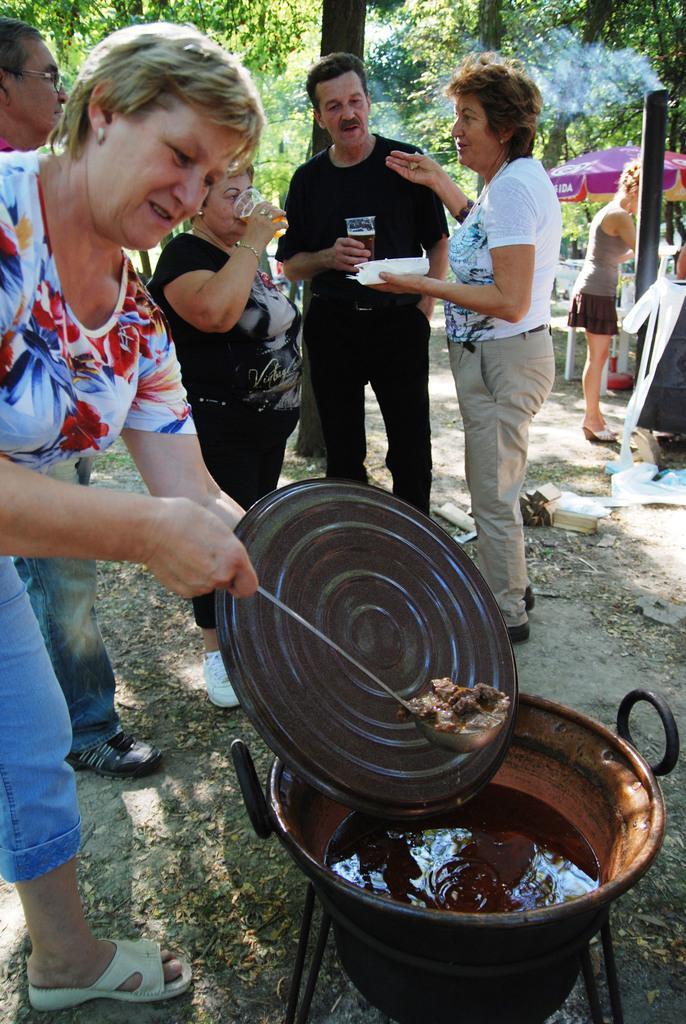Describe this image in one or two sentences. This image is taken outdoors. In the background there are a few trees. On the right side of the image there is an umbrella and there are a few empty chairs. A woman is standing on the ground and there is a pole. On the left side of the image a woman is holding a lid and a spatula with food in her hands and there is a vessel with a food item in it. In the middle of the image a man and two women are standing on the ground and they are holding glasses in their hands. 